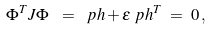<formula> <loc_0><loc_0><loc_500><loc_500>\Phi ^ { T } J \Phi \ & = \ \ p h + \epsilon \ p h ^ { T } \ = \ 0 \, ,</formula> 